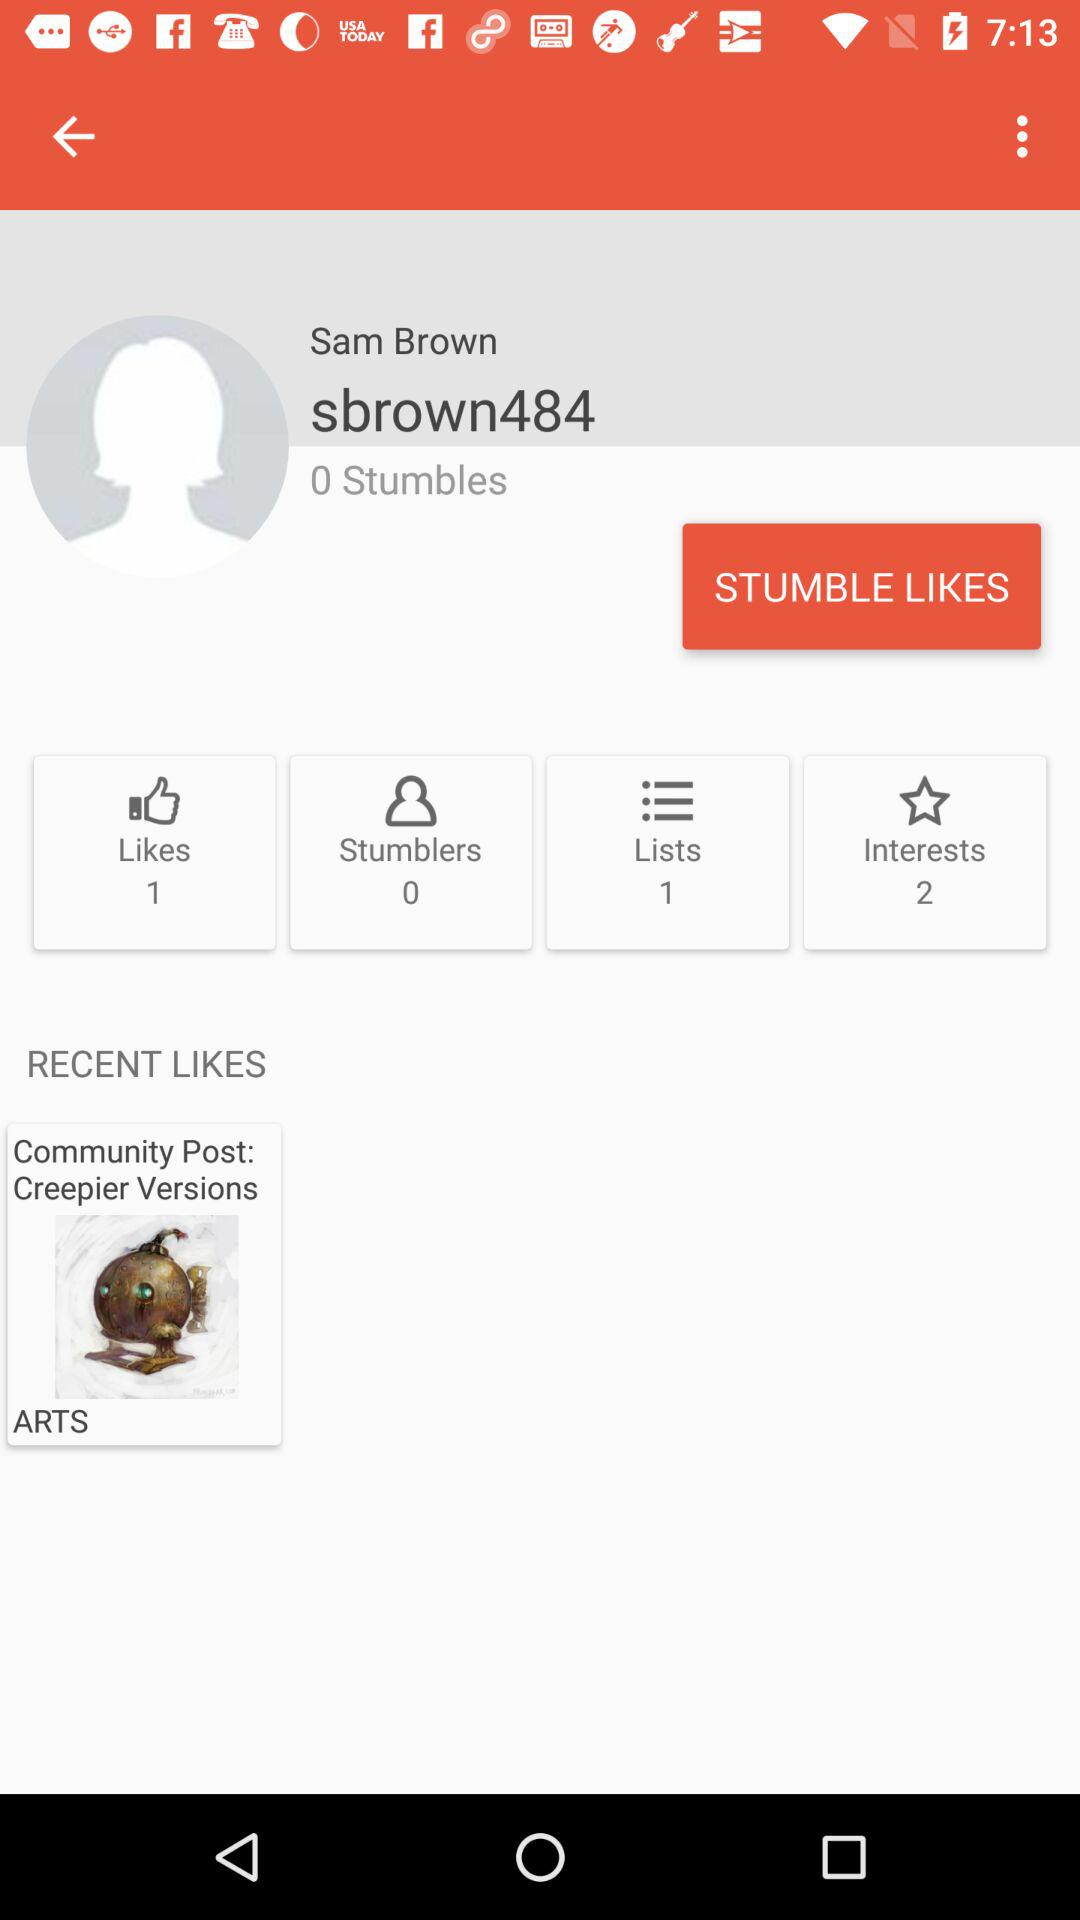What is the number of interests? The number of interests is 2. 